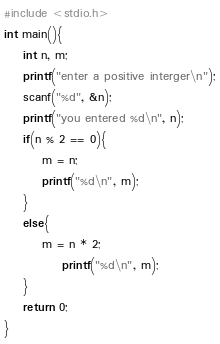Convert code to text. <code><loc_0><loc_0><loc_500><loc_500><_Awk_>#include <stdio.h>
int main(){
	int n, m;
	printf("enter a positive interger\n");
	scanf("%d", &n);
	printf("you entered %d\n", n);
	if(n % 2 == 0){
		m = n;
		printf("%d\n", m);
	}
	else{
		m = n * 2;
			printf("%d\n", m);
	}	
	return 0;
}</code> 